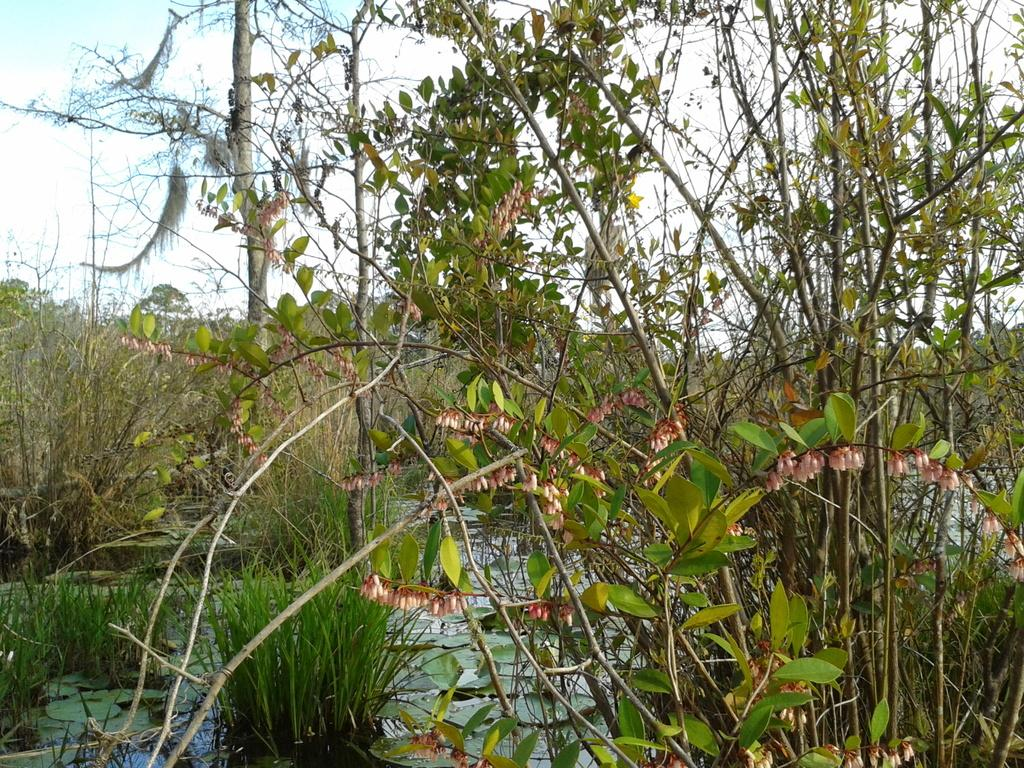What type of vegetation can be seen in the image? There are trees in the image. What is present at the bottom of the image? There is grass at the bottom of the image. What else can be found among the trees in the image? There are leaves in the image. What is visible at the top of the image? The sky is visible at the top of the image. What type of lunch is being served in the image? There is no lunch present in the image; it features trees, grass, leaves, and the sky. What is the border between the trees and the grass in the image? There is no specific border between the trees and the grass in the image; they are intermingled in the scene. 